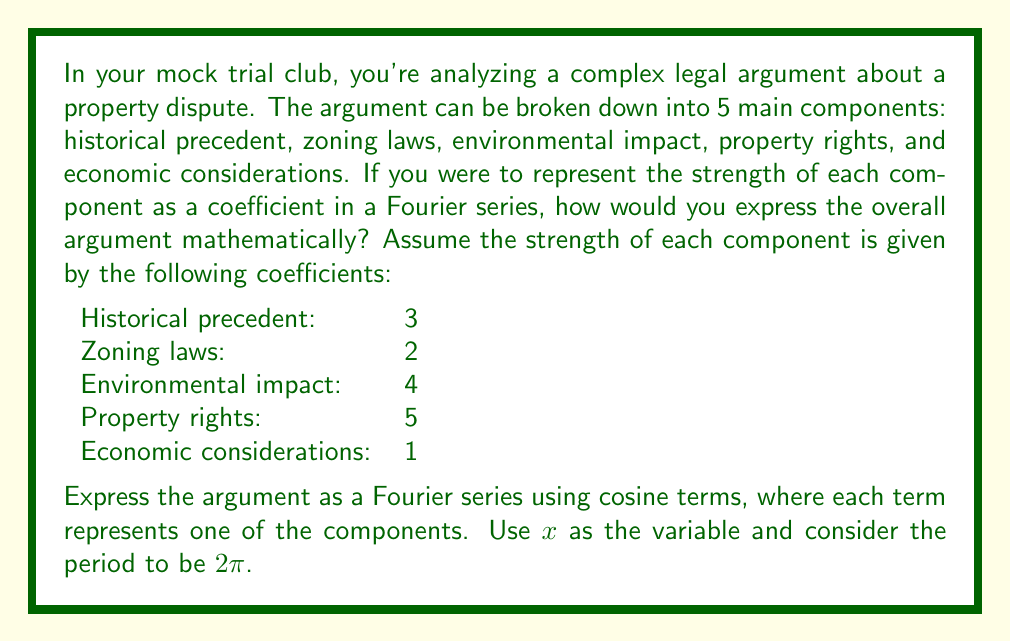Provide a solution to this math problem. To express this legal argument as a Fourier series, we'll use the general form of a Fourier cosine series:

$$f(x) = \frac{a_0}{2} + \sum_{n=1}^{\infty} a_n \cos(nx)$$

Where $a_n$ are the coefficients representing the strength of each component.

In this case, we have 5 components, so we'll use the first 5 terms of the series (n = 1 to 5):

1. Historical precedent: $a_1 = 3$
2. Zoning laws: $a_2 = 2$
3. Environmental impact: $a_3 = 4$
4. Property rights: $a_4 = 5$
5. Economic considerations: $a_5 = 1$

We don't have a constant term ($a_0$), so we can omit it.

Now, let's construct the Fourier series:

$$f(x) = 3\cos(x) + 2\cos(2x) + 4\cos(3x) + 5\cos(4x) + \cos(5x)$$

This expression represents the complex legal argument broken down into its component parts, where:
- The coefficient of each term represents the strength of that component
- The frequency (1x, 2x, 3x, etc.) represents the order of importance or consideration in the argument
- $x$ can be thought of as a variable representing the progression of the argument or the angle at which it's being considered

This mathematical representation allows for a quantitative analysis of the argument's components and their relative strengths.
Answer: $$f(x) = 3\cos(x) + 2\cos(2x) + 4\cos(3x) + 5\cos(4x) + \cos(5x)$$ 